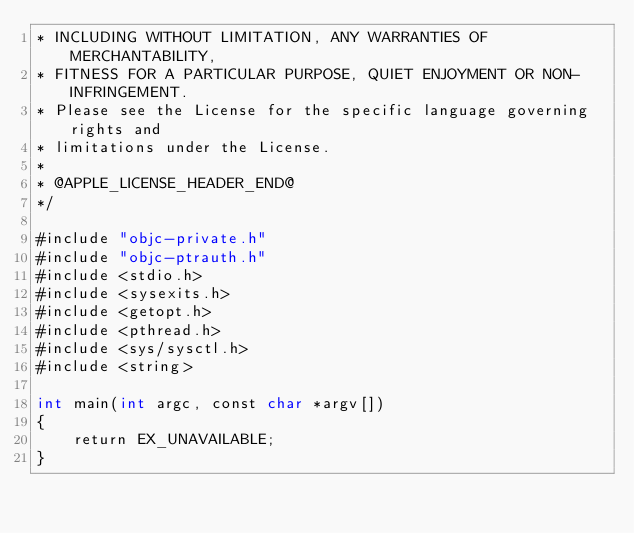<code> <loc_0><loc_0><loc_500><loc_500><_ObjectiveC_>* INCLUDING WITHOUT LIMITATION, ANY WARRANTIES OF MERCHANTABILITY,
* FITNESS FOR A PARTICULAR PURPOSE, QUIET ENJOYMENT OR NON-INFRINGEMENT.
* Please see the License for the specific language governing rights and
* limitations under the License.
*
* @APPLE_LICENSE_HEADER_END@
*/

#include "objc-private.h"
#include "objc-ptrauth.h"
#include <stdio.h>
#include <sysexits.h>
#include <getopt.h>
#include <pthread.h>
#include <sys/sysctl.h>
#include <string>

int main(int argc, const char *argv[])
{
    return EX_UNAVAILABLE;
}
</code> 